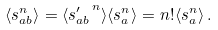<formula> <loc_0><loc_0><loc_500><loc_500>\langle s _ { a b } ^ { n } \rangle = \langle { s ^ { \prime } _ { a b } } ^ { \, n } \rangle \langle s _ { a } ^ { n } \rangle = n ! \langle s _ { a } ^ { n } \rangle \, .</formula> 